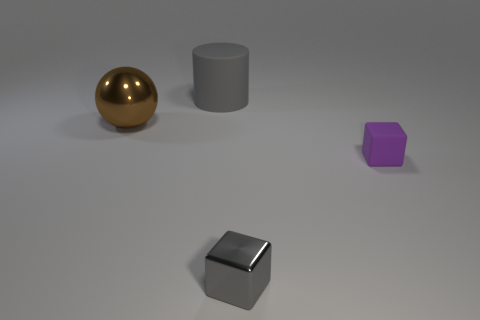How many cyan objects are matte things or big spheres?
Keep it short and to the point. 0. What number of cylinders have the same color as the tiny shiny cube?
Ensure brevity in your answer.  1. Are the purple cube and the gray cylinder made of the same material?
Make the answer very short. Yes. How many small rubber blocks are behind the small cube that is in front of the tiny purple block?
Your answer should be compact. 1. Do the gray rubber cylinder and the sphere have the same size?
Your answer should be compact. Yes. How many cubes have the same material as the large sphere?
Your response must be concise. 1. There is a gray object that is the same shape as the purple rubber thing; what is its size?
Your answer should be compact. Small. There is a shiny object in front of the tiny purple rubber block; is its shape the same as the purple rubber object?
Ensure brevity in your answer.  Yes. The rubber object that is on the left side of the matte object that is on the right side of the big matte object is what shape?
Your answer should be compact. Cylinder. Is there anything else that is the same shape as the brown thing?
Ensure brevity in your answer.  No. 